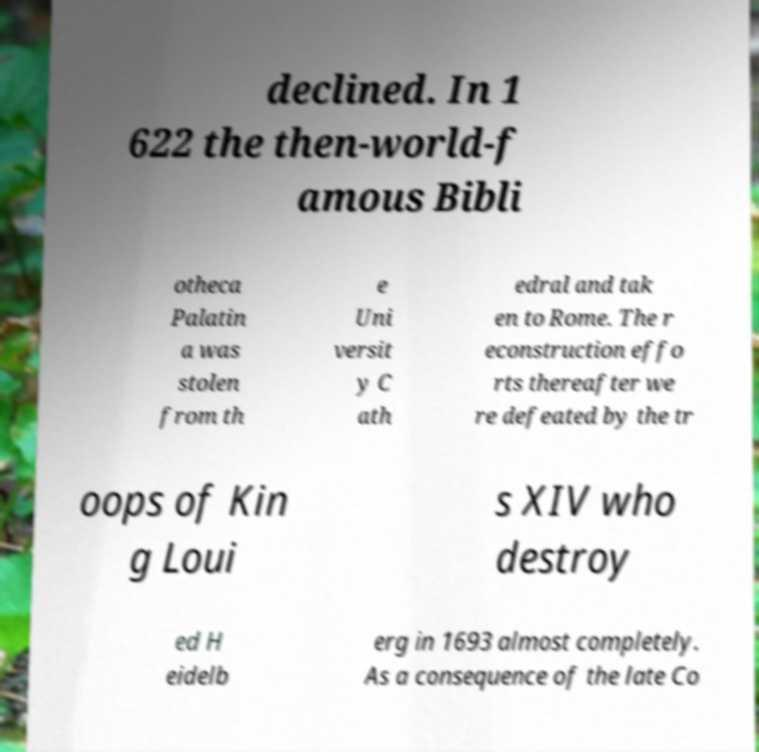What messages or text are displayed in this image? I need them in a readable, typed format. declined. In 1 622 the then-world-f amous Bibli otheca Palatin a was stolen from th e Uni versit y C ath edral and tak en to Rome. The r econstruction effo rts thereafter we re defeated by the tr oops of Kin g Loui s XIV who destroy ed H eidelb erg in 1693 almost completely. As a consequence of the late Co 